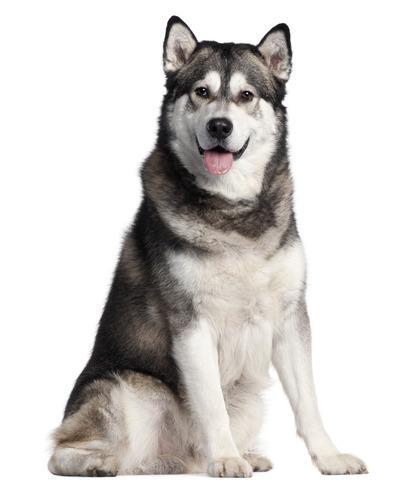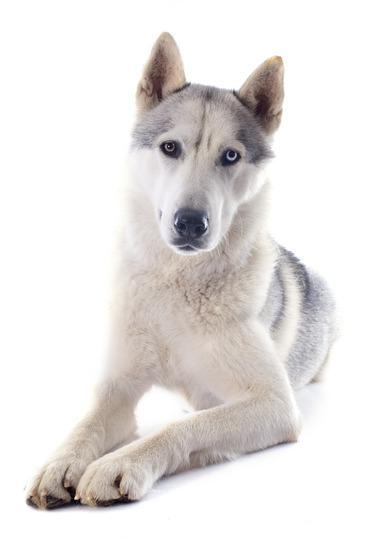The first image is the image on the left, the second image is the image on the right. Assess this claim about the two images: "The left image features two huskies side by side, with at least one sitting upright, and the right image contains two dogs, with at least one reclining.". Correct or not? Answer yes or no. No. The first image is the image on the left, the second image is the image on the right. Given the left and right images, does the statement "In at least one image there are two dogs and at least one is a very young husky puppy." hold true? Answer yes or no. No. 